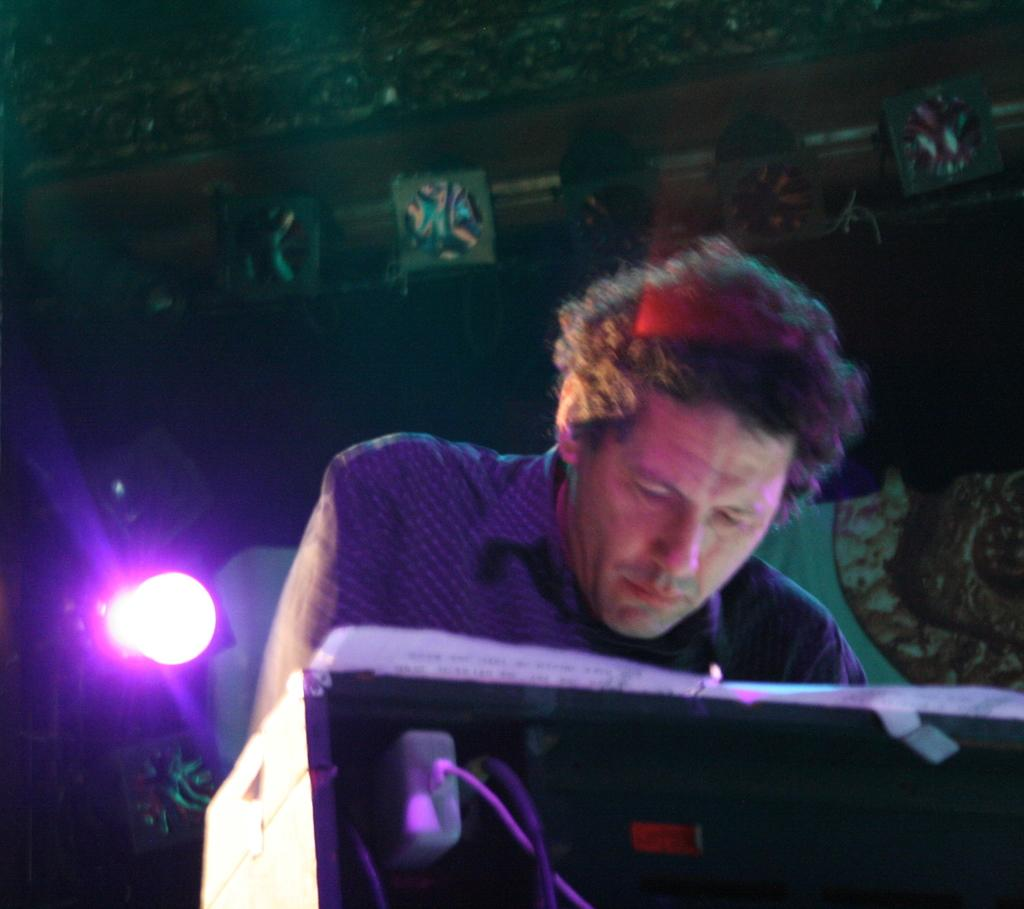What is the man near the desk doing in the image? There is a man standing near a desk in the image. What is on the desk that the man is standing near? There is a paper on the desk. What is the other man in the image doing? Another man is looking at the paper. What can be seen in the background of the image? There is a focus light in the background of the image. What color is the focus light? The focus light is blue in color. How many toes are visible in the image? There are no visible toes in the image. What type of lettuce is being used as a prop in the image? There is no lettuce present in the image. 